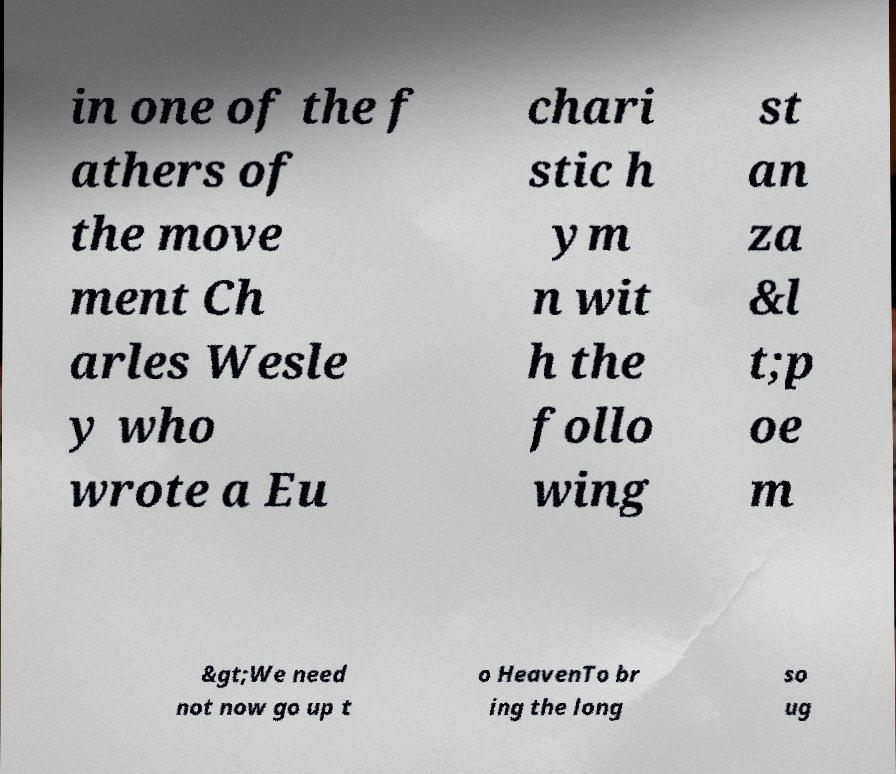There's text embedded in this image that I need extracted. Can you transcribe it verbatim? in one of the f athers of the move ment Ch arles Wesle y who wrote a Eu chari stic h ym n wit h the follo wing st an za &l t;p oe m &gt;We need not now go up t o HeavenTo br ing the long so ug 